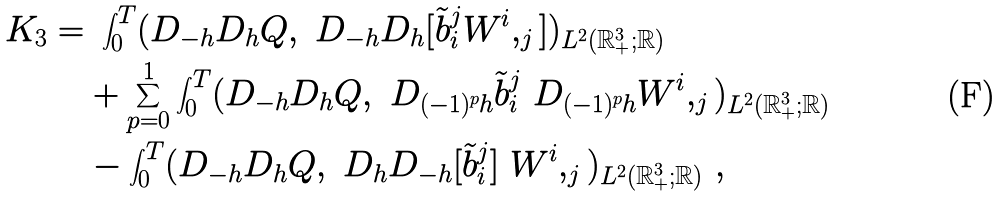Convert formula to latex. <formula><loc_0><loc_0><loc_500><loc_500>K _ { 3 } = & \ \int _ { 0 } ^ { T } ( D _ { - h } D _ { h } Q , \ D _ { - h } D _ { h } [ \tilde { b } _ { i } ^ { j } W ^ { i } , _ { j } ] ) _ { L ^ { 2 } ( { \mathbb { R } } ^ { 3 } _ { + } ; { \mathbb { R } } ) } \\ & + \sum _ { p = 0 } ^ { 1 } \int _ { 0 } ^ { T } ( D _ { - h } D _ { h } Q , \ D _ { ( - 1 ) ^ { p } h } \tilde { b } _ { i } ^ { j } \ D _ { ( - 1 ) ^ { p } h } W ^ { i } , _ { j } ) _ { L ^ { 2 } ( { \mathbb { R } } ^ { 3 } _ { + } ; { \mathbb { R } } ) } \\ & - \int _ { 0 } ^ { T } ( D _ { - h } D _ { h } Q , \ D _ { h } D _ { - h } [ \tilde { b } _ { i } ^ { j } ] \ W ^ { i } , _ { j } ) _ { L ^ { 2 } ( { \mathbb { R } } ^ { 3 } _ { + } ; { \mathbb { R } } ) } \ ,</formula> 